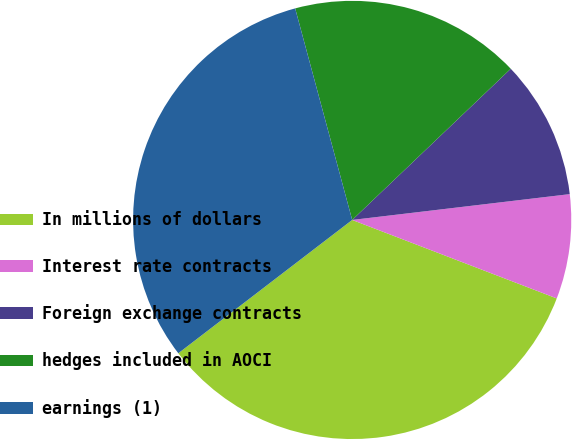Convert chart to OTSL. <chart><loc_0><loc_0><loc_500><loc_500><pie_chart><fcel>In millions of dollars<fcel>Interest rate contracts<fcel>Foreign exchange contracts<fcel>hedges included in AOCI<fcel>earnings (1)<nl><fcel>33.76%<fcel>7.71%<fcel>10.24%<fcel>17.07%<fcel>31.22%<nl></chart> 